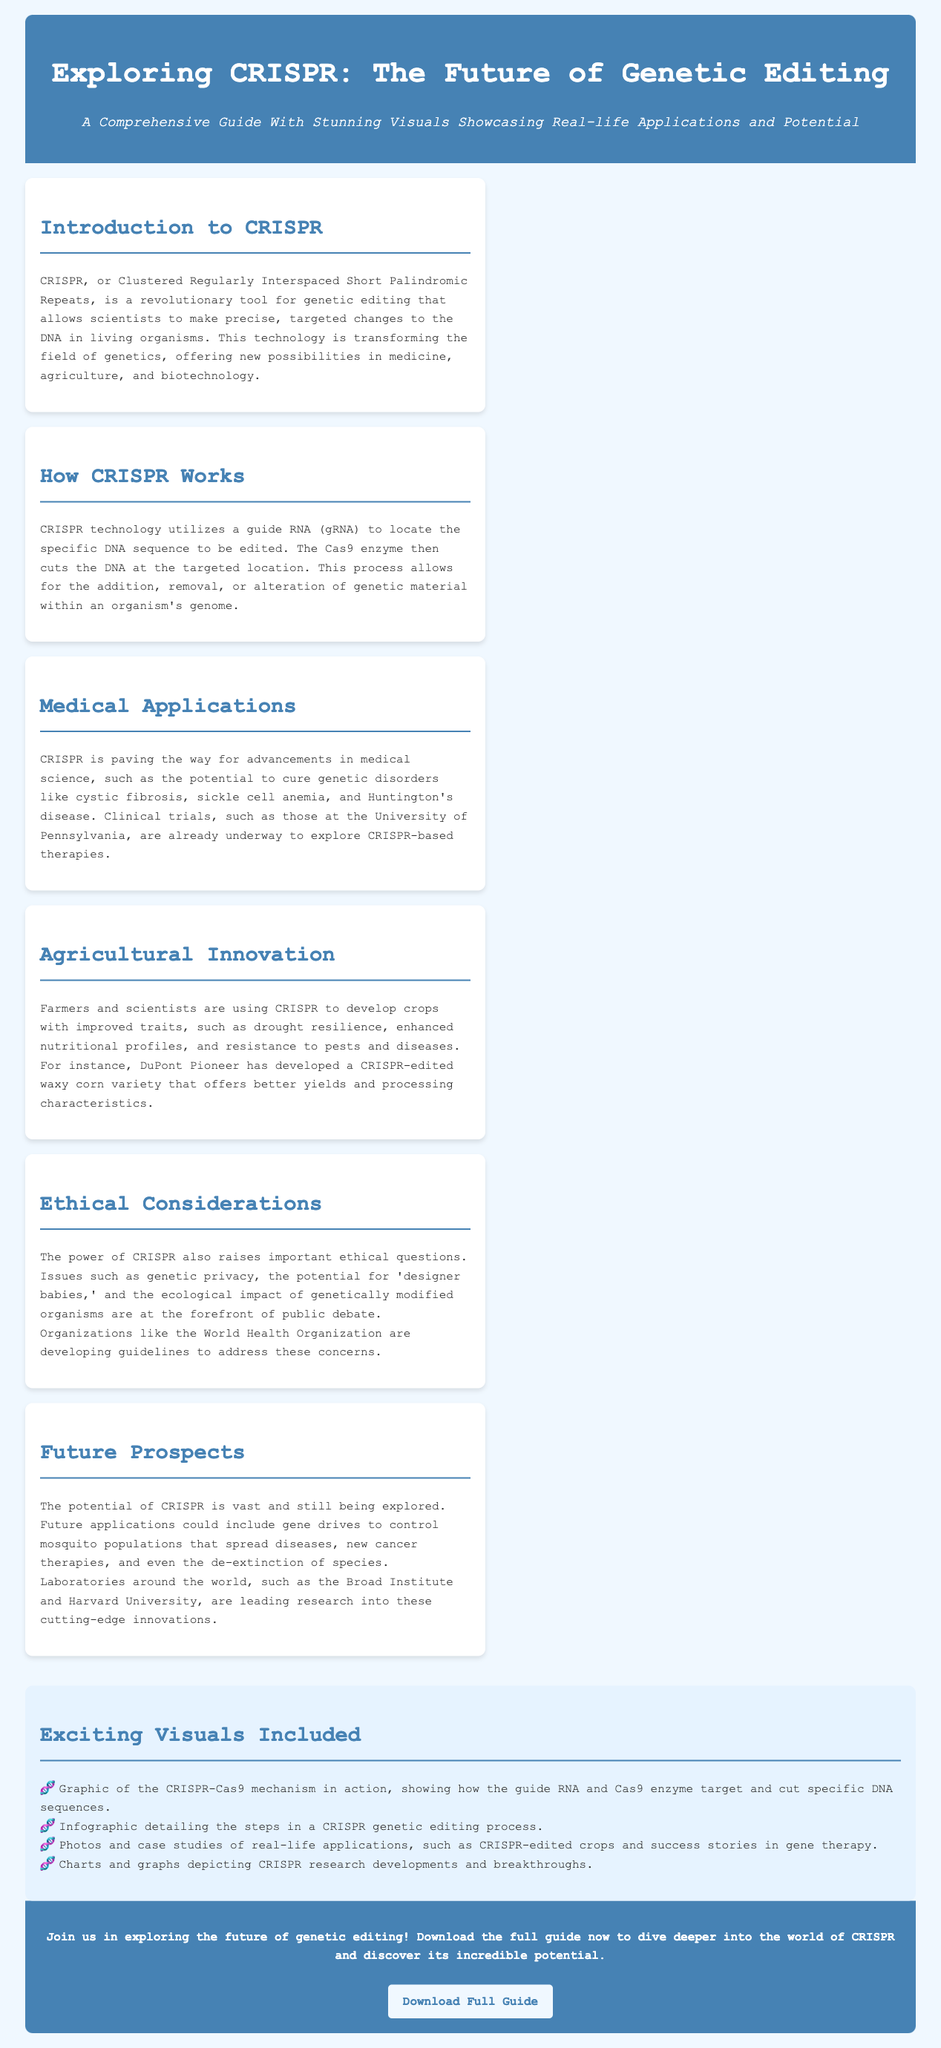What is CRISPR? CRISPR is described as Clustered Regularly Interspaced Short Palindromic Repeats, a tool for genetic editing.
Answer: Clustered Regularly Interspaced Short Palindromic Repeats What does the Cas9 enzyme do? The Cas9 enzyme is responsible for cutting the DNA at the targeted location during the CRISPR process.
Answer: Cuts DNA Which university is mentioned in relation to clinical trials? The University of Pennsylvania is noted for conducting clinical trials exploring CRISPR-based therapies.
Answer: University of Pennsylvania What crop variety is developed by DuPont Pioneer? DuPont Pioneer has developed a CRISPR-edited waxy corn variety that has better yields.
Answer: Waxy corn What ethical issue is raised by CRISPR technology? The document mentions genetic privacy among the ethical concerns related to CRISPR.
Answer: Genetic privacy What type of organisms could gene drives potentially control? Gene drives could be used to control mosquito populations that spread diseases.
Answer: Mosquito populations What is included in the visuals section? The visuals section includes graphics of the CRISPR-Cas9 mechanism and charts detailing research developments.
Answer: Graphics of the CRISPR-Cas9 mechanism How can one explore more about CRISPR? The advertisement suggests downloading the full guide for a deeper exploration of CRISPR.
Answer: Download the full guide 